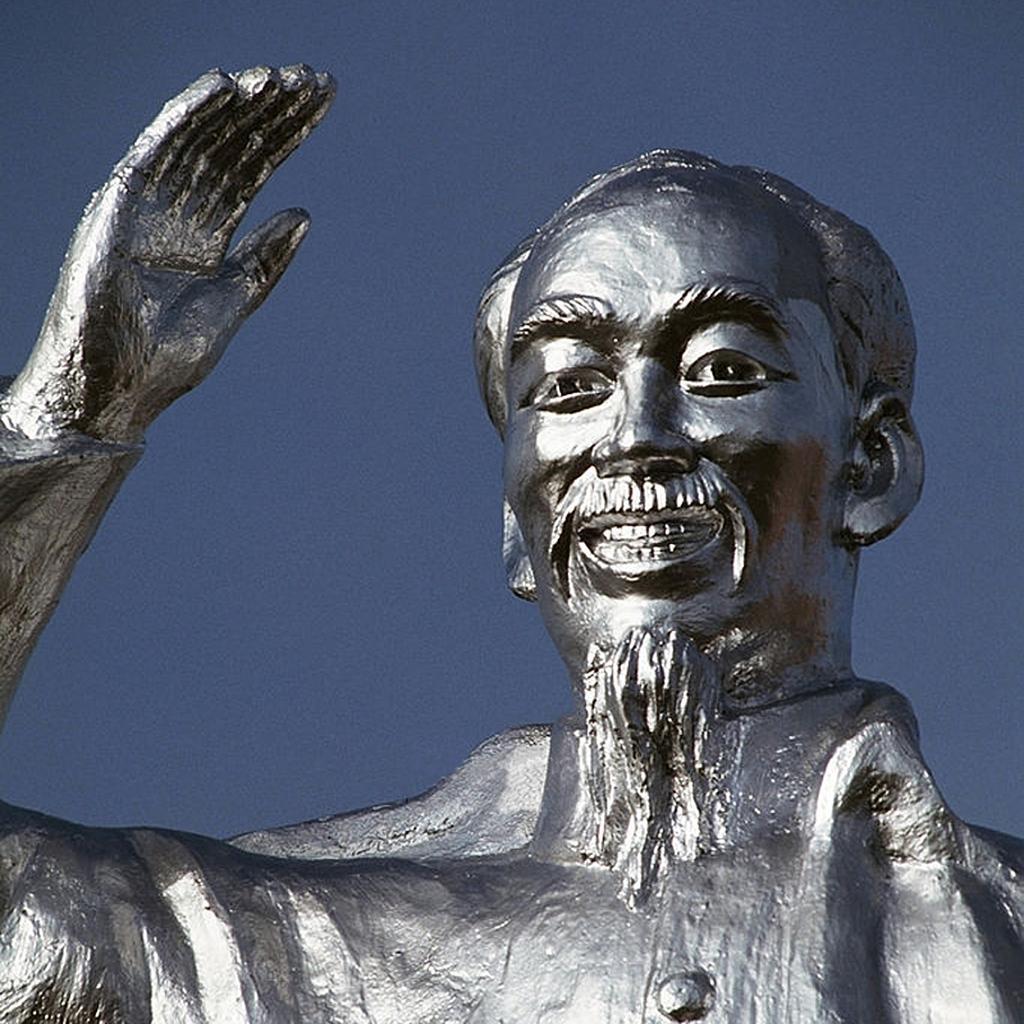Can you describe this image briefly? In this image I can see a person statue. It is in silver color. Background is in blue color. 